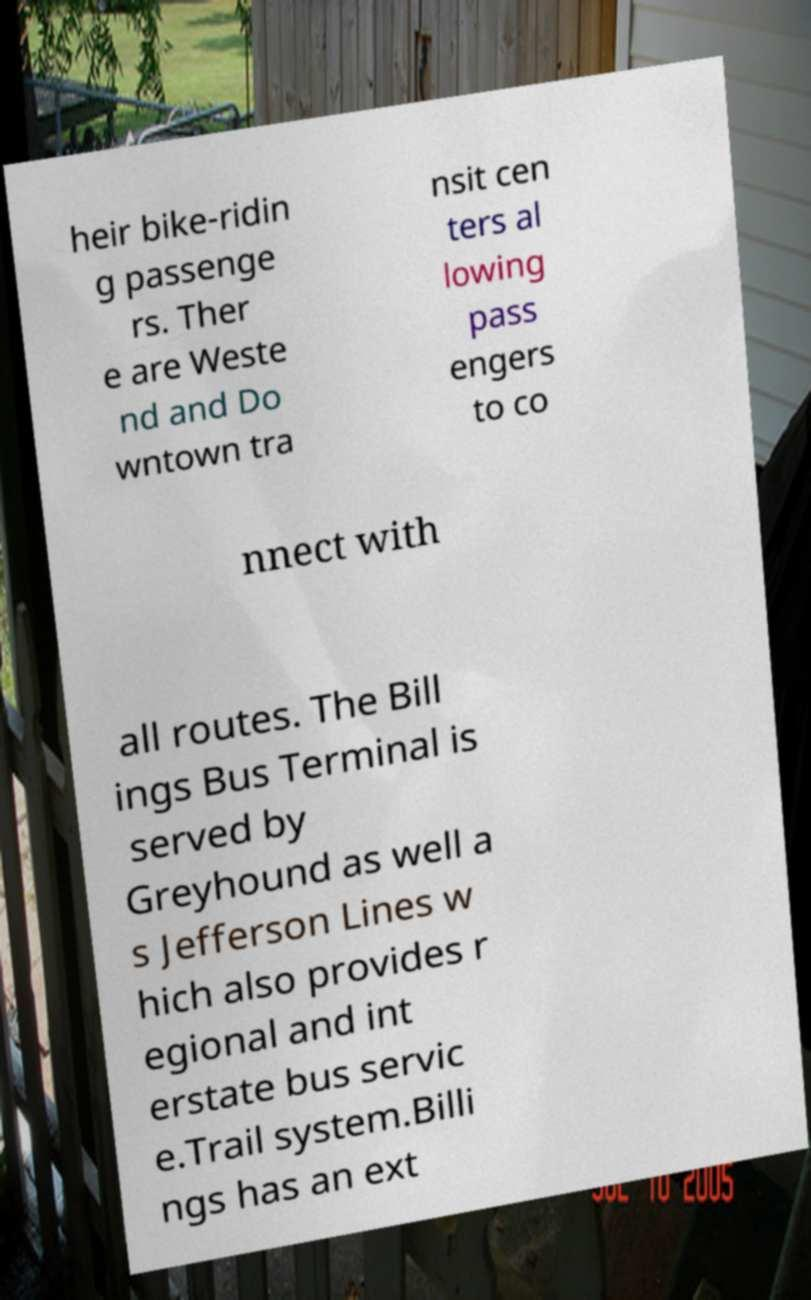Can you accurately transcribe the text from the provided image for me? heir bike-ridin g passenge rs. Ther e are Weste nd and Do wntown tra nsit cen ters al lowing pass engers to co nnect with all routes. The Bill ings Bus Terminal is served by Greyhound as well a s Jefferson Lines w hich also provides r egional and int erstate bus servic e.Trail system.Billi ngs has an ext 